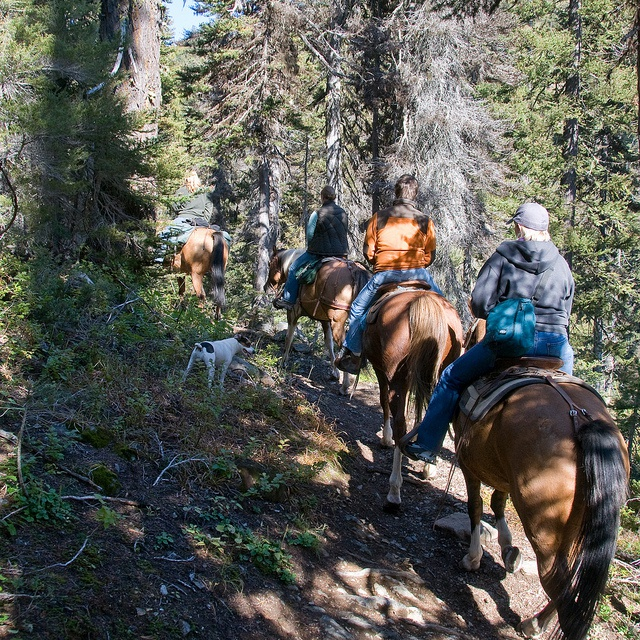Describe the objects in this image and their specific colors. I can see horse in gray, black, and maroon tones, people in gray, black, lavender, navy, and darkgray tones, horse in gray, black, and tan tones, people in gray, black, lightgray, and brown tones, and horse in gray and black tones in this image. 